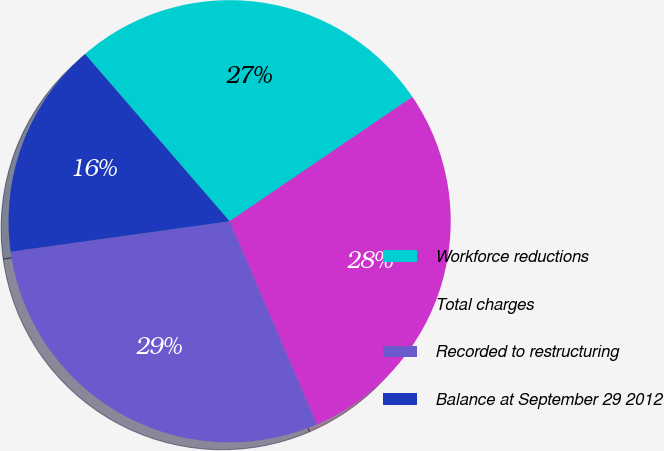Convert chart to OTSL. <chart><loc_0><loc_0><loc_500><loc_500><pie_chart><fcel>Workforce reductions<fcel>Total charges<fcel>Recorded to restructuring<fcel>Balance at September 29 2012<nl><fcel>26.84%<fcel>28.05%<fcel>29.26%<fcel>15.85%<nl></chart> 